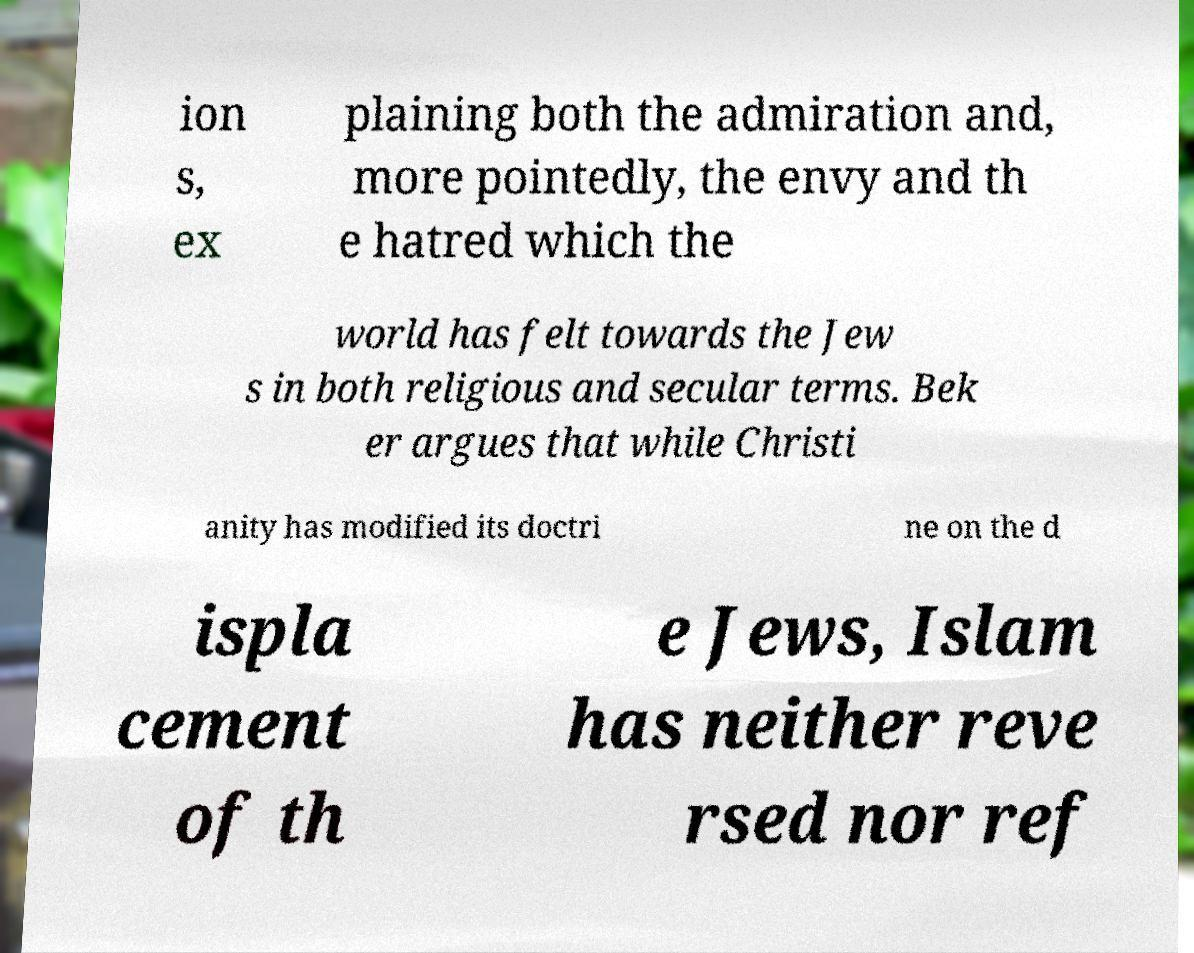Could you assist in decoding the text presented in this image and type it out clearly? ion s, ex plaining both the admiration and, more pointedly, the envy and th e hatred which the world has felt towards the Jew s in both religious and secular terms. Bek er argues that while Christi anity has modified its doctri ne on the d ispla cement of th e Jews, Islam has neither reve rsed nor ref 